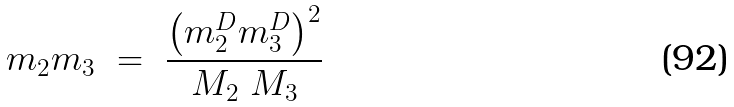<formula> <loc_0><loc_0><loc_500><loc_500>m _ { 2 } m _ { 3 } \ = \ \frac { \left ( m _ { 2 } ^ { D } m _ { 3 } ^ { D } \right ) ^ { 2 } } { M _ { 2 } \ M _ { 3 } } \ \,</formula> 